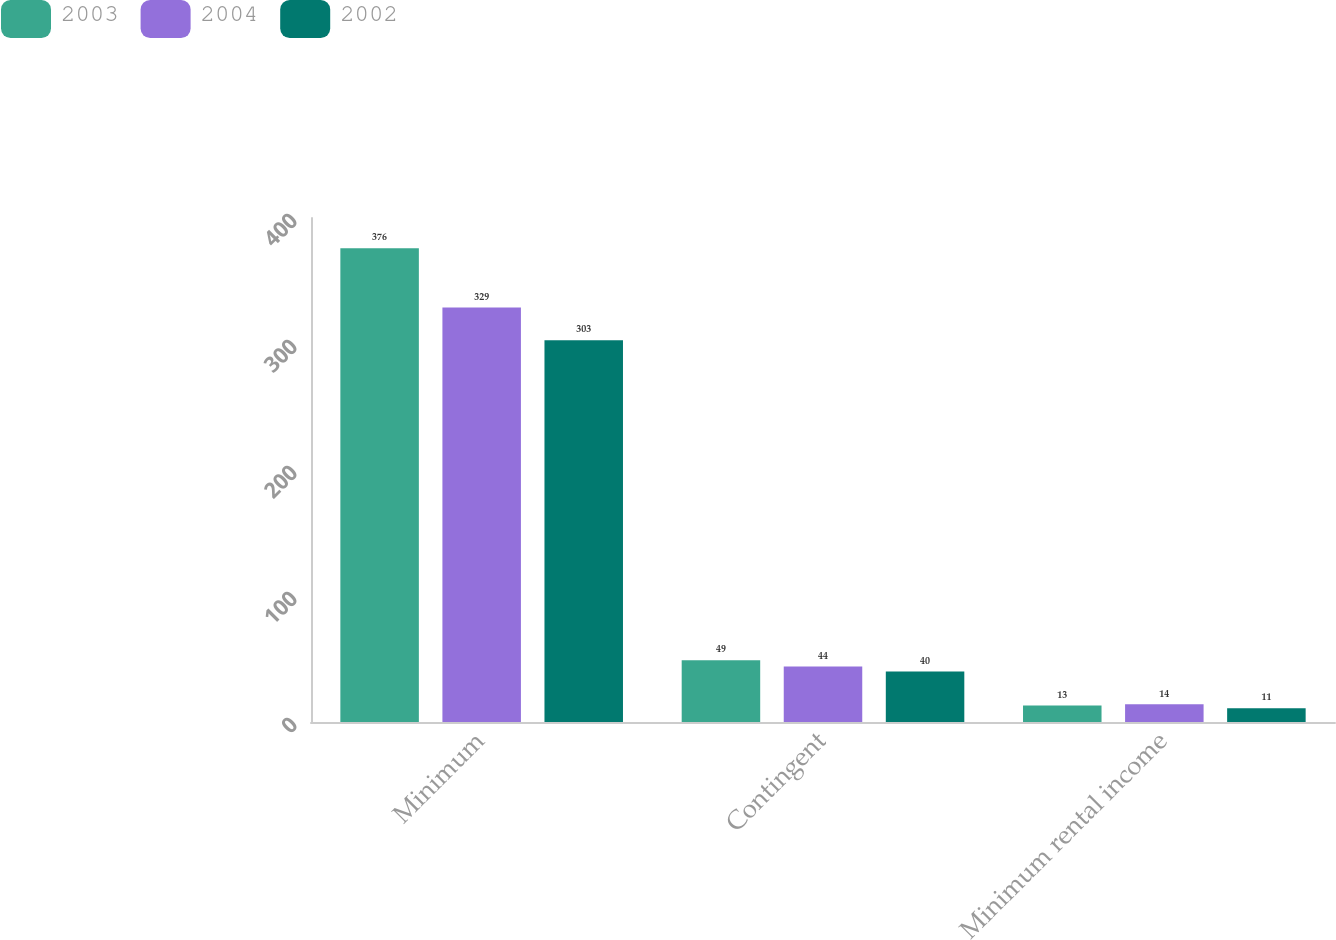<chart> <loc_0><loc_0><loc_500><loc_500><stacked_bar_chart><ecel><fcel>Minimum<fcel>Contingent<fcel>Minimum rental income<nl><fcel>2003<fcel>376<fcel>49<fcel>13<nl><fcel>2004<fcel>329<fcel>44<fcel>14<nl><fcel>2002<fcel>303<fcel>40<fcel>11<nl></chart> 